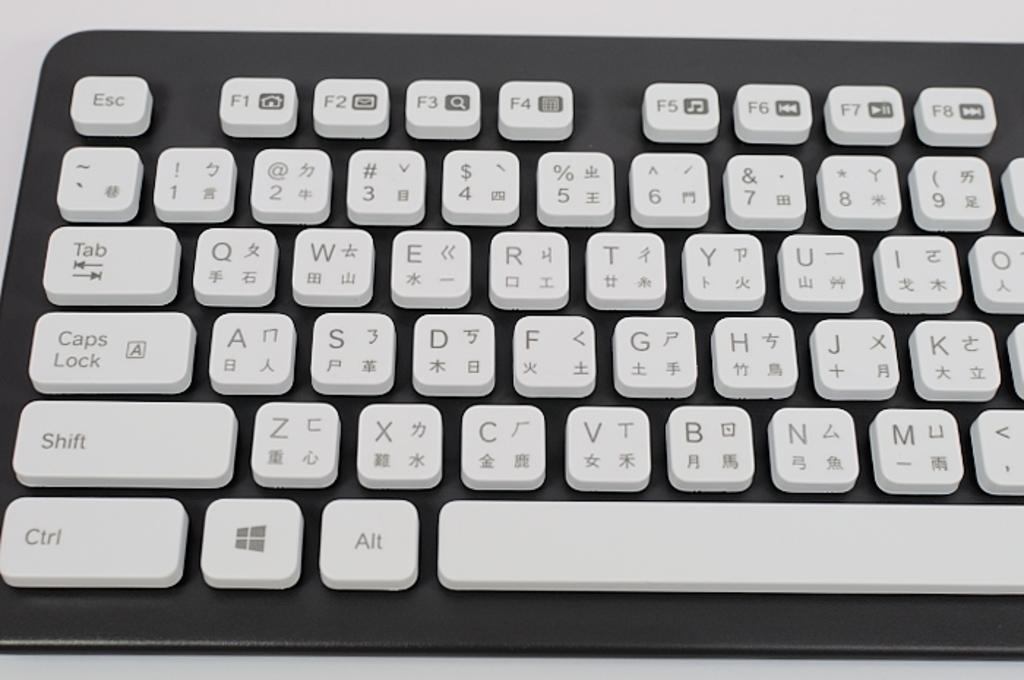<image>
Describe the image concisely. A computer keyboard has a Windows logo between the Ctrl and Alt buttons. 